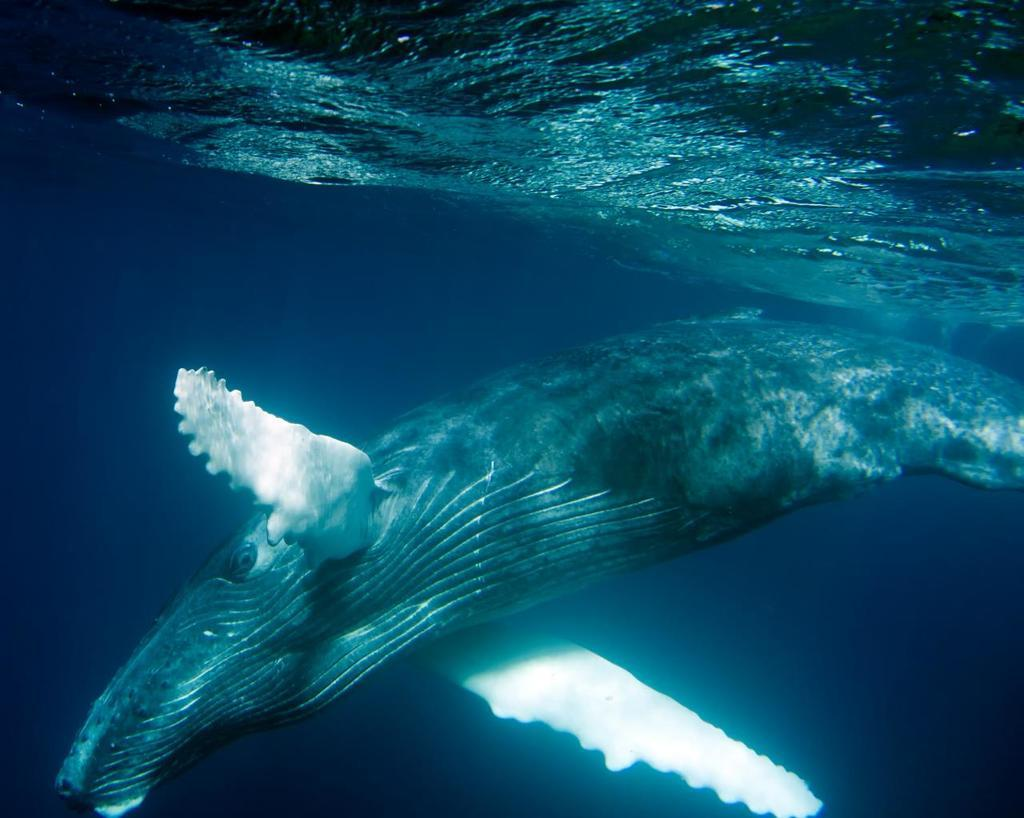What is visible in the image? There is water visible in the image. What can be found in the water? There is a fish in the water. What type of yard can be seen in the image? There is no yard present in the image; it only features water and a fish. Is there a gun visible in the image? No, there is no gun present in the image. 